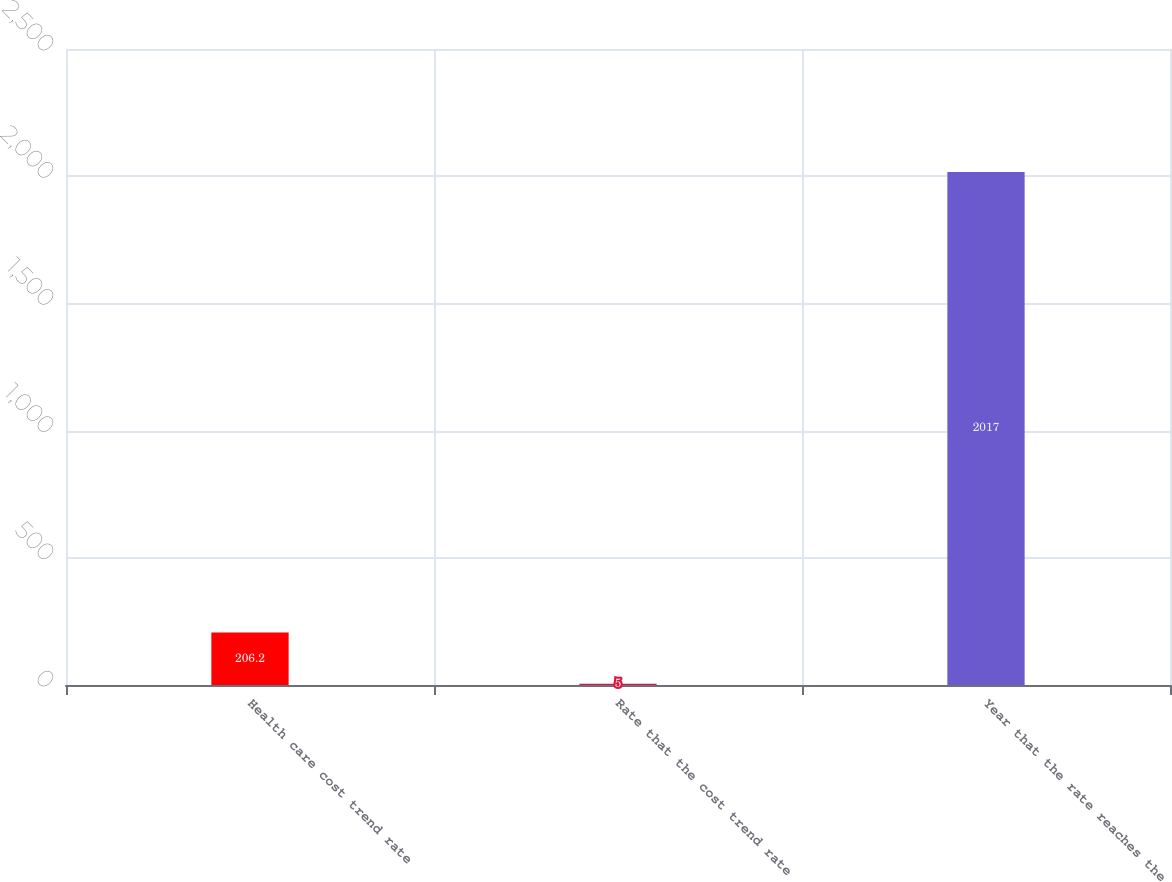<chart> <loc_0><loc_0><loc_500><loc_500><bar_chart><fcel>Health care cost trend rate<fcel>Rate that the cost trend rate<fcel>Year that the rate reaches the<nl><fcel>206.2<fcel>5<fcel>2017<nl></chart> 